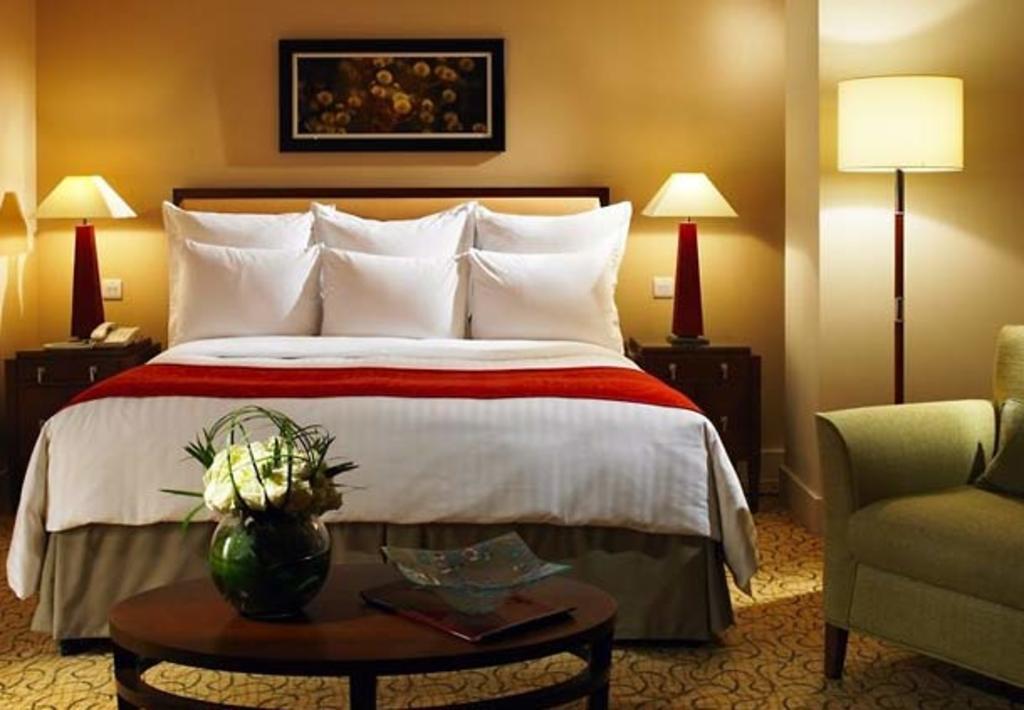Describe this image in one or two sentences. This is a picture of a bedroom where there is a flower pot and a glass plate in the table and a bed with white and red color blanket , 6 pillows , a photo frame attached to the wall , and a lamp up of the cupboard , and a lamp in the carpet and a couch. 